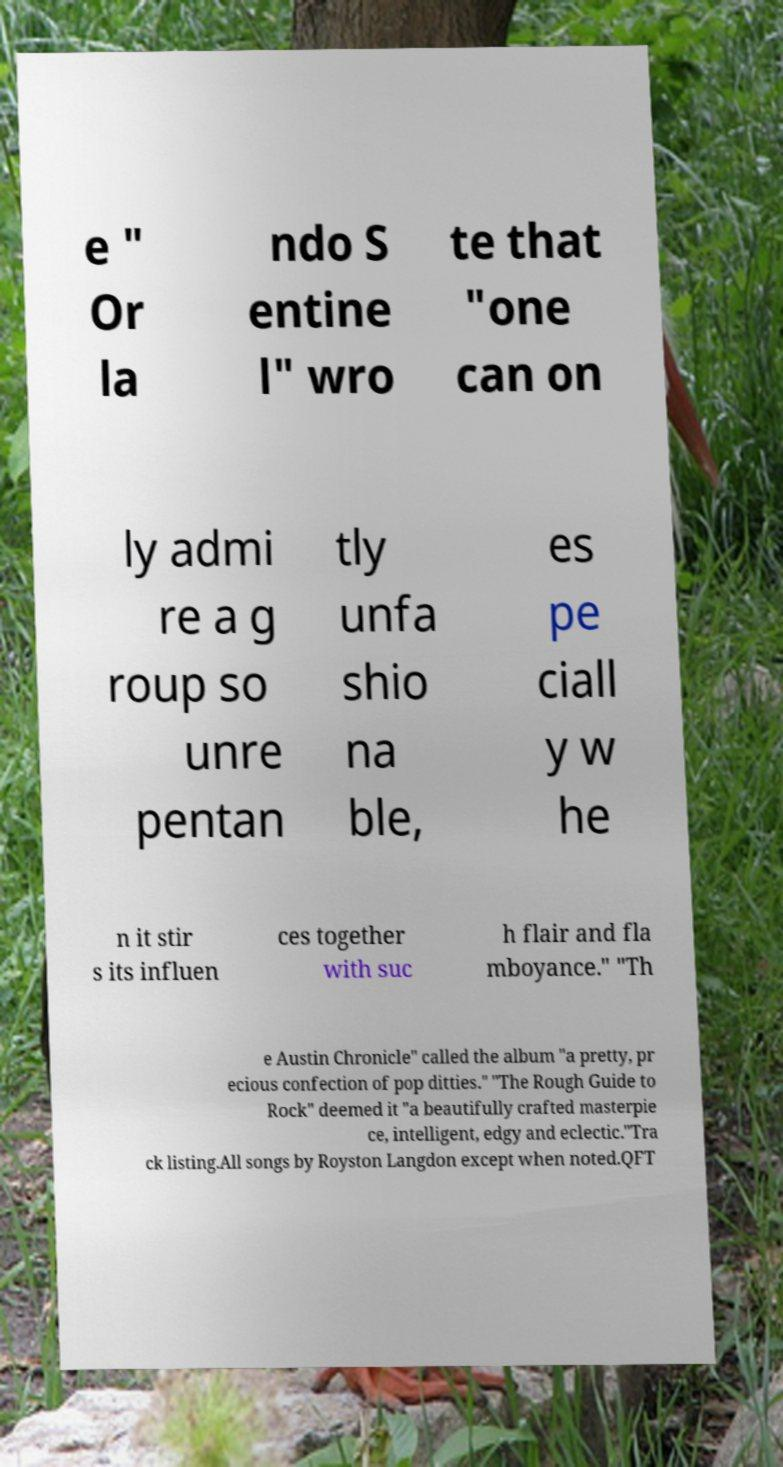Please identify and transcribe the text found in this image. e " Or la ndo S entine l" wro te that "one can on ly admi re a g roup so unre pentan tly unfa shio na ble, es pe ciall y w he n it stir s its influen ces together with suc h flair and fla mboyance." "Th e Austin Chronicle" called the album "a pretty, pr ecious confection of pop ditties." "The Rough Guide to Rock" deemed it "a beautifully crafted masterpie ce, intelligent, edgy and eclectic."Tra ck listing.All songs by Royston Langdon except when noted.QFT 